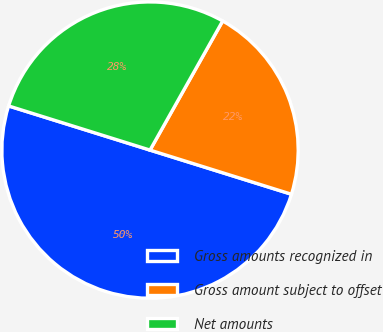<chart> <loc_0><loc_0><loc_500><loc_500><pie_chart><fcel>Gross amounts recognized in<fcel>Gross amount subject to offset<fcel>Net amounts<nl><fcel>50.0%<fcel>21.66%<fcel>28.34%<nl></chart> 